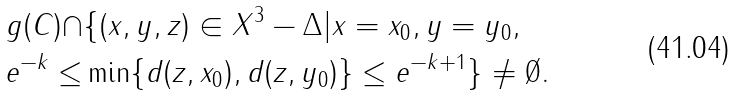Convert formula to latex. <formula><loc_0><loc_0><loc_500><loc_500>g ( C ) \cap & \{ ( x , y , z ) \in X ^ { 3 } - \Delta | x = x _ { 0 } , y = y _ { 0 } , \\ e ^ { - k } \leq & \min \{ d ( z , x _ { 0 } ) , d ( z , y _ { 0 } ) \} \leq e ^ { - k + 1 } \} \not = \emptyset .</formula> 